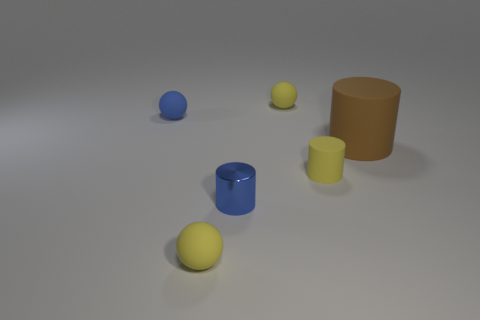How many other objects are there of the same size as the metallic cylinder?
Your answer should be compact. 4. There is a yellow ball that is to the left of the object behind the small blue rubber thing; what is it made of?
Ensure brevity in your answer.  Rubber. There is a brown rubber cylinder; does it have the same size as the yellow matte object that is in front of the yellow cylinder?
Your answer should be compact. No. Are there any shiny things that have the same color as the big cylinder?
Give a very brief answer. No. What number of tiny things are either gray metal spheres or rubber objects?
Offer a terse response. 4. How many big brown rubber things are there?
Your answer should be very brief. 1. There is a blue object behind the big brown cylinder; what material is it?
Keep it short and to the point. Rubber. Are there any blue objects left of the yellow rubber cylinder?
Your answer should be very brief. Yes. Do the metal object and the yellow cylinder have the same size?
Provide a succinct answer. Yes. What number of other blue cylinders are the same material as the big cylinder?
Provide a short and direct response. 0. 